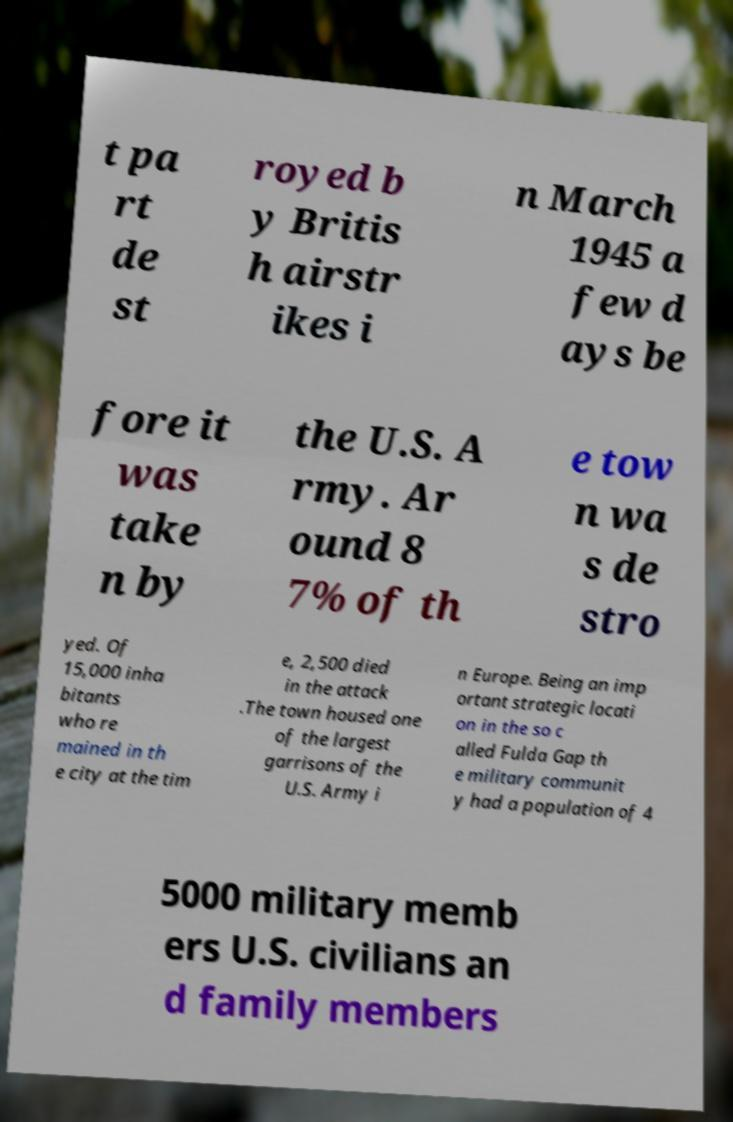For documentation purposes, I need the text within this image transcribed. Could you provide that? t pa rt de st royed b y Britis h airstr ikes i n March 1945 a few d ays be fore it was take n by the U.S. A rmy. Ar ound 8 7% of th e tow n wa s de stro yed. Of 15,000 inha bitants who re mained in th e city at the tim e, 2,500 died in the attack .The town housed one of the largest garrisons of the U.S. Army i n Europe. Being an imp ortant strategic locati on in the so c alled Fulda Gap th e military communit y had a population of 4 5000 military memb ers U.S. civilians an d family members 